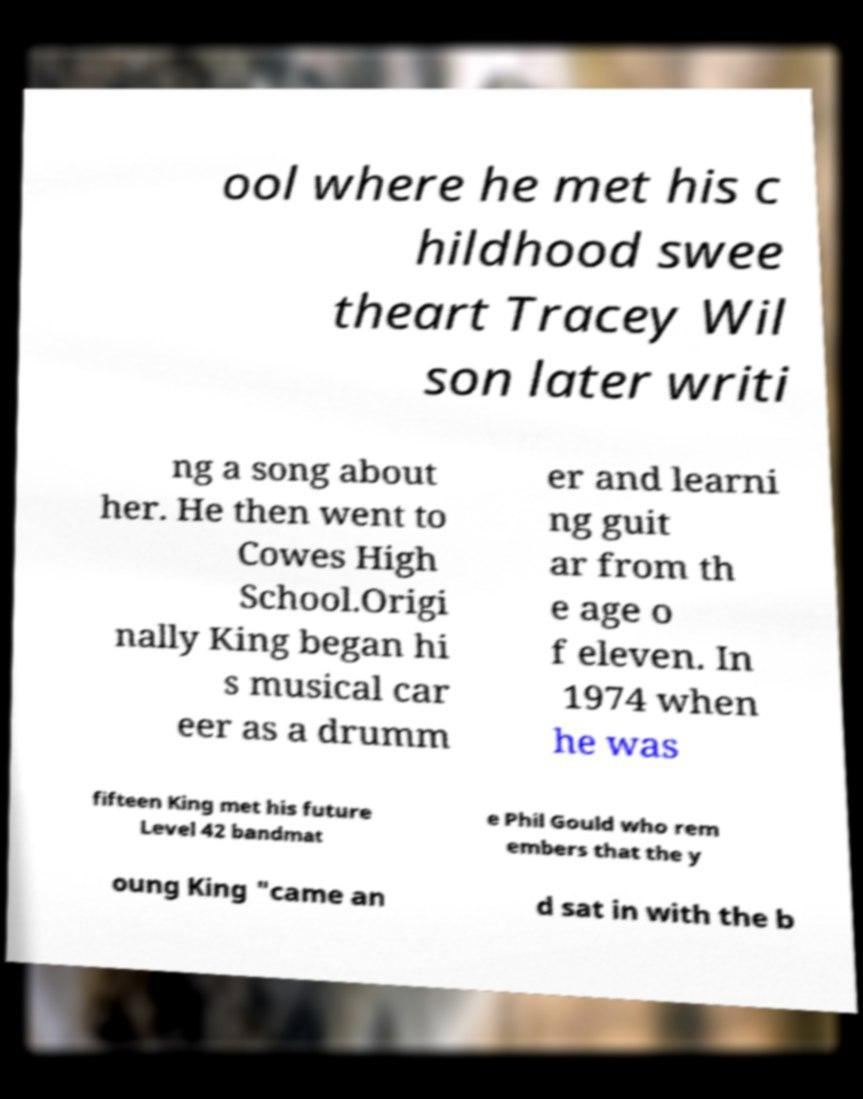For documentation purposes, I need the text within this image transcribed. Could you provide that? ool where he met his c hildhood swee theart Tracey Wil son later writi ng a song about her. He then went to Cowes High School.Origi nally King began hi s musical car eer as a drumm er and learni ng guit ar from th e age o f eleven. In 1974 when he was fifteen King met his future Level 42 bandmat e Phil Gould who rem embers that the y oung King "came an d sat in with the b 